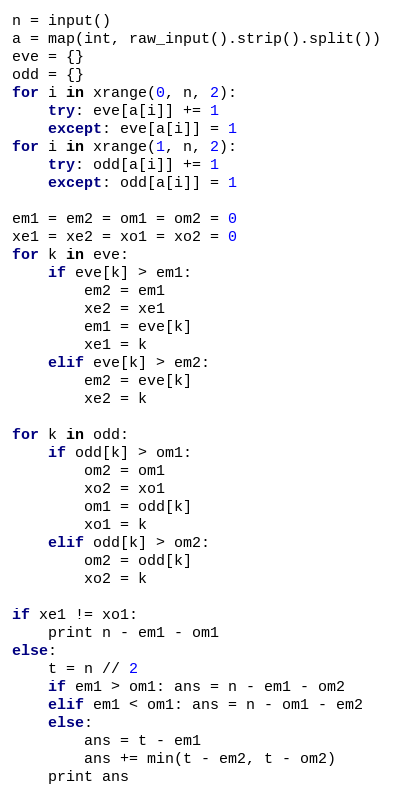Convert code to text. <code><loc_0><loc_0><loc_500><loc_500><_Python_>n = input()
a = map(int, raw_input().strip().split())
eve = {}
odd = {}
for i in xrange(0, n, 2):
    try: eve[a[i]] += 1
    except: eve[a[i]] = 1
for i in xrange(1, n, 2):
    try: odd[a[i]] += 1
    except: odd[a[i]] = 1
    
em1 = em2 = om1 = om2 = 0
xe1 = xe2 = xo1 = xo2 = 0
for k in eve:
    if eve[k] > em1:
        em2 = em1
        xe2 = xe1
        em1 = eve[k]
        xe1 = k
    elif eve[k] > em2:
        em2 = eve[k]
        xe2 = k
    
for k in odd:
    if odd[k] > om1:
        om2 = om1
        xo2 = xo1
        om1 = odd[k]
        xo1 = k
    elif odd[k] > om2:
        om2 = odd[k]
        xo2 = k

if xe1 != xo1:
    print n - em1 - om1
else:
    t = n // 2
    if em1 > om1: ans = n - em1 - om2
    elif em1 < om1: ans = n - om1 - em2
    else:
        ans = t - em1
        ans += min(t - em2, t - om2)
    print ans
</code> 